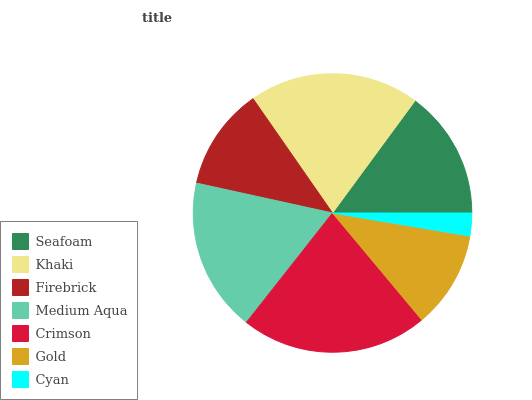Is Cyan the minimum?
Answer yes or no. Yes. Is Crimson the maximum?
Answer yes or no. Yes. Is Khaki the minimum?
Answer yes or no. No. Is Khaki the maximum?
Answer yes or no. No. Is Khaki greater than Seafoam?
Answer yes or no. Yes. Is Seafoam less than Khaki?
Answer yes or no. Yes. Is Seafoam greater than Khaki?
Answer yes or no. No. Is Khaki less than Seafoam?
Answer yes or no. No. Is Seafoam the high median?
Answer yes or no. Yes. Is Seafoam the low median?
Answer yes or no. Yes. Is Cyan the high median?
Answer yes or no. No. Is Cyan the low median?
Answer yes or no. No. 